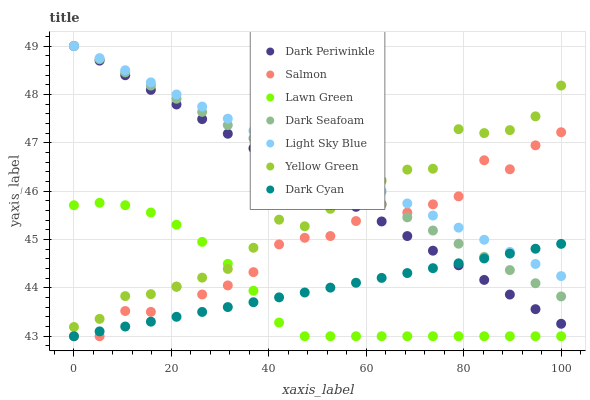Does Lawn Green have the minimum area under the curve?
Answer yes or no. Yes. Does Light Sky Blue have the maximum area under the curve?
Answer yes or no. Yes. Does Yellow Green have the minimum area under the curve?
Answer yes or no. No. Does Yellow Green have the maximum area under the curve?
Answer yes or no. No. Is Dark Seafoam the smoothest?
Answer yes or no. Yes. Is Salmon the roughest?
Answer yes or no. Yes. Is Yellow Green the smoothest?
Answer yes or no. No. Is Yellow Green the roughest?
Answer yes or no. No. Does Lawn Green have the lowest value?
Answer yes or no. Yes. Does Yellow Green have the lowest value?
Answer yes or no. No. Does Dark Periwinkle have the highest value?
Answer yes or no. Yes. Does Yellow Green have the highest value?
Answer yes or no. No. Is Salmon less than Yellow Green?
Answer yes or no. Yes. Is Yellow Green greater than Dark Cyan?
Answer yes or no. Yes. Does Dark Seafoam intersect Yellow Green?
Answer yes or no. Yes. Is Dark Seafoam less than Yellow Green?
Answer yes or no. No. Is Dark Seafoam greater than Yellow Green?
Answer yes or no. No. Does Salmon intersect Yellow Green?
Answer yes or no. No. 